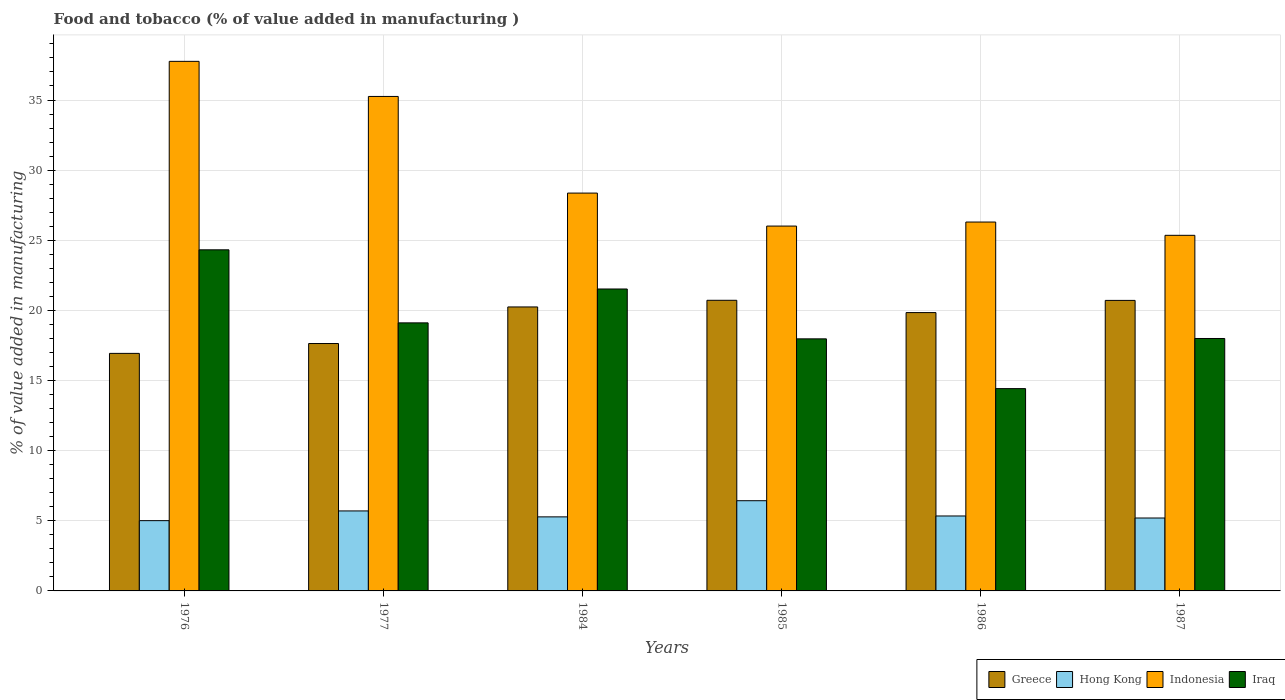Are the number of bars on each tick of the X-axis equal?
Offer a terse response. Yes. How many bars are there on the 3rd tick from the right?
Keep it short and to the point. 4. What is the label of the 1st group of bars from the left?
Keep it short and to the point. 1976. In how many cases, is the number of bars for a given year not equal to the number of legend labels?
Provide a short and direct response. 0. What is the value added in manufacturing food and tobacco in Iraq in 1985?
Make the answer very short. 17.97. Across all years, what is the maximum value added in manufacturing food and tobacco in Greece?
Ensure brevity in your answer.  20.72. Across all years, what is the minimum value added in manufacturing food and tobacco in Greece?
Ensure brevity in your answer.  16.93. In which year was the value added in manufacturing food and tobacco in Hong Kong minimum?
Your response must be concise. 1976. What is the total value added in manufacturing food and tobacco in Hong Kong in the graph?
Make the answer very short. 32.97. What is the difference between the value added in manufacturing food and tobacco in Hong Kong in 1984 and that in 1986?
Ensure brevity in your answer.  -0.06. What is the difference between the value added in manufacturing food and tobacco in Greece in 1977 and the value added in manufacturing food and tobacco in Iraq in 1976?
Keep it short and to the point. -6.68. What is the average value added in manufacturing food and tobacco in Indonesia per year?
Offer a terse response. 29.84. In the year 1987, what is the difference between the value added in manufacturing food and tobacco in Greece and value added in manufacturing food and tobacco in Hong Kong?
Your answer should be very brief. 15.51. In how many years, is the value added in manufacturing food and tobacco in Iraq greater than 22 %?
Give a very brief answer. 1. What is the ratio of the value added in manufacturing food and tobacco in Indonesia in 1976 to that in 1985?
Make the answer very short. 1.45. Is the value added in manufacturing food and tobacco in Hong Kong in 1977 less than that in 1986?
Keep it short and to the point. No. What is the difference between the highest and the second highest value added in manufacturing food and tobacco in Hong Kong?
Provide a short and direct response. 0.73. What is the difference between the highest and the lowest value added in manufacturing food and tobacco in Iraq?
Your answer should be compact. 9.9. Is it the case that in every year, the sum of the value added in manufacturing food and tobacco in Iraq and value added in manufacturing food and tobacco in Hong Kong is greater than the sum of value added in manufacturing food and tobacco in Greece and value added in manufacturing food and tobacco in Indonesia?
Your answer should be compact. Yes. What does the 2nd bar from the left in 1985 represents?
Ensure brevity in your answer.  Hong Kong. What does the 2nd bar from the right in 1977 represents?
Provide a short and direct response. Indonesia. Is it the case that in every year, the sum of the value added in manufacturing food and tobacco in Hong Kong and value added in manufacturing food and tobacco in Indonesia is greater than the value added in manufacturing food and tobacco in Iraq?
Your answer should be compact. Yes. How many bars are there?
Keep it short and to the point. 24. How many years are there in the graph?
Your answer should be very brief. 6. Are the values on the major ticks of Y-axis written in scientific E-notation?
Your answer should be compact. No. Does the graph contain grids?
Offer a very short reply. Yes. How are the legend labels stacked?
Your response must be concise. Horizontal. What is the title of the graph?
Make the answer very short. Food and tobacco (% of value added in manufacturing ). What is the label or title of the Y-axis?
Offer a very short reply. % of value added in manufacturing. What is the % of value added in manufacturing in Greece in 1976?
Provide a succinct answer. 16.93. What is the % of value added in manufacturing of Hong Kong in 1976?
Provide a short and direct response. 5.01. What is the % of value added in manufacturing in Indonesia in 1976?
Your answer should be very brief. 37.76. What is the % of value added in manufacturing in Iraq in 1976?
Provide a succinct answer. 24.32. What is the % of value added in manufacturing of Greece in 1977?
Your response must be concise. 17.64. What is the % of value added in manufacturing in Hong Kong in 1977?
Give a very brief answer. 5.7. What is the % of value added in manufacturing in Indonesia in 1977?
Offer a very short reply. 35.25. What is the % of value added in manufacturing of Iraq in 1977?
Your answer should be very brief. 19.11. What is the % of value added in manufacturing in Greece in 1984?
Your answer should be very brief. 20.25. What is the % of value added in manufacturing in Hong Kong in 1984?
Ensure brevity in your answer.  5.28. What is the % of value added in manufacturing in Indonesia in 1984?
Provide a short and direct response. 28.36. What is the % of value added in manufacturing of Iraq in 1984?
Provide a short and direct response. 21.53. What is the % of value added in manufacturing in Greece in 1985?
Provide a succinct answer. 20.72. What is the % of value added in manufacturing of Hong Kong in 1985?
Provide a short and direct response. 6.43. What is the % of value added in manufacturing in Indonesia in 1985?
Your answer should be very brief. 26.01. What is the % of value added in manufacturing of Iraq in 1985?
Keep it short and to the point. 17.97. What is the % of value added in manufacturing of Greece in 1986?
Make the answer very short. 19.84. What is the % of value added in manufacturing in Hong Kong in 1986?
Give a very brief answer. 5.34. What is the % of value added in manufacturing in Indonesia in 1986?
Offer a very short reply. 26.3. What is the % of value added in manufacturing in Iraq in 1986?
Make the answer very short. 14.42. What is the % of value added in manufacturing of Greece in 1987?
Ensure brevity in your answer.  20.71. What is the % of value added in manufacturing of Hong Kong in 1987?
Offer a very short reply. 5.2. What is the % of value added in manufacturing of Indonesia in 1987?
Make the answer very short. 25.35. What is the % of value added in manufacturing of Iraq in 1987?
Your answer should be very brief. 18. Across all years, what is the maximum % of value added in manufacturing of Greece?
Make the answer very short. 20.72. Across all years, what is the maximum % of value added in manufacturing in Hong Kong?
Give a very brief answer. 6.43. Across all years, what is the maximum % of value added in manufacturing in Indonesia?
Ensure brevity in your answer.  37.76. Across all years, what is the maximum % of value added in manufacturing in Iraq?
Keep it short and to the point. 24.32. Across all years, what is the minimum % of value added in manufacturing of Greece?
Offer a terse response. 16.93. Across all years, what is the minimum % of value added in manufacturing in Hong Kong?
Keep it short and to the point. 5.01. Across all years, what is the minimum % of value added in manufacturing of Indonesia?
Provide a succinct answer. 25.35. Across all years, what is the minimum % of value added in manufacturing in Iraq?
Offer a terse response. 14.42. What is the total % of value added in manufacturing in Greece in the graph?
Your response must be concise. 116.1. What is the total % of value added in manufacturing of Hong Kong in the graph?
Keep it short and to the point. 32.97. What is the total % of value added in manufacturing of Indonesia in the graph?
Your response must be concise. 179.04. What is the total % of value added in manufacturing in Iraq in the graph?
Your response must be concise. 115.35. What is the difference between the % of value added in manufacturing of Greece in 1976 and that in 1977?
Your answer should be compact. -0.7. What is the difference between the % of value added in manufacturing of Hong Kong in 1976 and that in 1977?
Provide a succinct answer. -0.69. What is the difference between the % of value added in manufacturing of Indonesia in 1976 and that in 1977?
Your answer should be very brief. 2.5. What is the difference between the % of value added in manufacturing of Iraq in 1976 and that in 1977?
Your answer should be compact. 5.21. What is the difference between the % of value added in manufacturing of Greece in 1976 and that in 1984?
Your answer should be compact. -3.31. What is the difference between the % of value added in manufacturing of Hong Kong in 1976 and that in 1984?
Give a very brief answer. -0.27. What is the difference between the % of value added in manufacturing of Indonesia in 1976 and that in 1984?
Give a very brief answer. 9.39. What is the difference between the % of value added in manufacturing in Iraq in 1976 and that in 1984?
Provide a short and direct response. 2.79. What is the difference between the % of value added in manufacturing in Greece in 1976 and that in 1985?
Offer a terse response. -3.79. What is the difference between the % of value added in manufacturing in Hong Kong in 1976 and that in 1985?
Provide a short and direct response. -1.42. What is the difference between the % of value added in manufacturing in Indonesia in 1976 and that in 1985?
Your answer should be very brief. 11.74. What is the difference between the % of value added in manufacturing in Iraq in 1976 and that in 1985?
Offer a very short reply. 6.35. What is the difference between the % of value added in manufacturing of Greece in 1976 and that in 1986?
Provide a succinct answer. -2.91. What is the difference between the % of value added in manufacturing of Hong Kong in 1976 and that in 1986?
Make the answer very short. -0.33. What is the difference between the % of value added in manufacturing in Indonesia in 1976 and that in 1986?
Provide a succinct answer. 11.46. What is the difference between the % of value added in manufacturing in Iraq in 1976 and that in 1986?
Give a very brief answer. 9.9. What is the difference between the % of value added in manufacturing in Greece in 1976 and that in 1987?
Provide a short and direct response. -3.78. What is the difference between the % of value added in manufacturing of Hong Kong in 1976 and that in 1987?
Offer a terse response. -0.19. What is the difference between the % of value added in manufacturing in Indonesia in 1976 and that in 1987?
Provide a succinct answer. 12.4. What is the difference between the % of value added in manufacturing of Iraq in 1976 and that in 1987?
Keep it short and to the point. 6.32. What is the difference between the % of value added in manufacturing in Greece in 1977 and that in 1984?
Your response must be concise. -2.61. What is the difference between the % of value added in manufacturing of Hong Kong in 1977 and that in 1984?
Ensure brevity in your answer.  0.42. What is the difference between the % of value added in manufacturing in Indonesia in 1977 and that in 1984?
Make the answer very short. 6.89. What is the difference between the % of value added in manufacturing of Iraq in 1977 and that in 1984?
Offer a terse response. -2.42. What is the difference between the % of value added in manufacturing in Greece in 1977 and that in 1985?
Make the answer very short. -3.08. What is the difference between the % of value added in manufacturing in Hong Kong in 1977 and that in 1985?
Give a very brief answer. -0.73. What is the difference between the % of value added in manufacturing of Indonesia in 1977 and that in 1985?
Provide a succinct answer. 9.24. What is the difference between the % of value added in manufacturing of Iraq in 1977 and that in 1985?
Give a very brief answer. 1.14. What is the difference between the % of value added in manufacturing in Greece in 1977 and that in 1986?
Offer a very short reply. -2.21. What is the difference between the % of value added in manufacturing in Hong Kong in 1977 and that in 1986?
Keep it short and to the point. 0.36. What is the difference between the % of value added in manufacturing of Indonesia in 1977 and that in 1986?
Your answer should be compact. 8.95. What is the difference between the % of value added in manufacturing of Iraq in 1977 and that in 1986?
Your answer should be very brief. 4.69. What is the difference between the % of value added in manufacturing of Greece in 1977 and that in 1987?
Your answer should be very brief. -3.07. What is the difference between the % of value added in manufacturing of Hong Kong in 1977 and that in 1987?
Your response must be concise. 0.5. What is the difference between the % of value added in manufacturing in Indonesia in 1977 and that in 1987?
Ensure brevity in your answer.  9.9. What is the difference between the % of value added in manufacturing of Iraq in 1977 and that in 1987?
Your response must be concise. 1.11. What is the difference between the % of value added in manufacturing of Greece in 1984 and that in 1985?
Ensure brevity in your answer.  -0.48. What is the difference between the % of value added in manufacturing in Hong Kong in 1984 and that in 1985?
Your response must be concise. -1.15. What is the difference between the % of value added in manufacturing of Indonesia in 1984 and that in 1985?
Offer a very short reply. 2.35. What is the difference between the % of value added in manufacturing in Iraq in 1984 and that in 1985?
Ensure brevity in your answer.  3.56. What is the difference between the % of value added in manufacturing in Greece in 1984 and that in 1986?
Offer a very short reply. 0.4. What is the difference between the % of value added in manufacturing of Hong Kong in 1984 and that in 1986?
Your answer should be very brief. -0.06. What is the difference between the % of value added in manufacturing of Indonesia in 1984 and that in 1986?
Make the answer very short. 2.06. What is the difference between the % of value added in manufacturing in Iraq in 1984 and that in 1986?
Offer a very short reply. 7.1. What is the difference between the % of value added in manufacturing in Greece in 1984 and that in 1987?
Give a very brief answer. -0.47. What is the difference between the % of value added in manufacturing in Hong Kong in 1984 and that in 1987?
Offer a terse response. 0.08. What is the difference between the % of value added in manufacturing of Indonesia in 1984 and that in 1987?
Provide a short and direct response. 3.01. What is the difference between the % of value added in manufacturing in Iraq in 1984 and that in 1987?
Keep it short and to the point. 3.53. What is the difference between the % of value added in manufacturing in Greece in 1985 and that in 1986?
Provide a short and direct response. 0.88. What is the difference between the % of value added in manufacturing in Hong Kong in 1985 and that in 1986?
Your response must be concise. 1.09. What is the difference between the % of value added in manufacturing in Indonesia in 1985 and that in 1986?
Offer a terse response. -0.29. What is the difference between the % of value added in manufacturing of Iraq in 1985 and that in 1986?
Make the answer very short. 3.55. What is the difference between the % of value added in manufacturing of Greece in 1985 and that in 1987?
Ensure brevity in your answer.  0.01. What is the difference between the % of value added in manufacturing in Hong Kong in 1985 and that in 1987?
Keep it short and to the point. 1.23. What is the difference between the % of value added in manufacturing of Indonesia in 1985 and that in 1987?
Keep it short and to the point. 0.66. What is the difference between the % of value added in manufacturing in Iraq in 1985 and that in 1987?
Your response must be concise. -0.03. What is the difference between the % of value added in manufacturing in Greece in 1986 and that in 1987?
Your answer should be compact. -0.87. What is the difference between the % of value added in manufacturing in Hong Kong in 1986 and that in 1987?
Provide a succinct answer. 0.15. What is the difference between the % of value added in manufacturing of Indonesia in 1986 and that in 1987?
Offer a very short reply. 0.95. What is the difference between the % of value added in manufacturing in Iraq in 1986 and that in 1987?
Keep it short and to the point. -3.57. What is the difference between the % of value added in manufacturing in Greece in 1976 and the % of value added in manufacturing in Hong Kong in 1977?
Make the answer very short. 11.23. What is the difference between the % of value added in manufacturing in Greece in 1976 and the % of value added in manufacturing in Indonesia in 1977?
Give a very brief answer. -18.32. What is the difference between the % of value added in manufacturing of Greece in 1976 and the % of value added in manufacturing of Iraq in 1977?
Give a very brief answer. -2.18. What is the difference between the % of value added in manufacturing in Hong Kong in 1976 and the % of value added in manufacturing in Indonesia in 1977?
Offer a very short reply. -30.24. What is the difference between the % of value added in manufacturing in Hong Kong in 1976 and the % of value added in manufacturing in Iraq in 1977?
Give a very brief answer. -14.1. What is the difference between the % of value added in manufacturing of Indonesia in 1976 and the % of value added in manufacturing of Iraq in 1977?
Provide a short and direct response. 18.64. What is the difference between the % of value added in manufacturing of Greece in 1976 and the % of value added in manufacturing of Hong Kong in 1984?
Provide a short and direct response. 11.66. What is the difference between the % of value added in manufacturing of Greece in 1976 and the % of value added in manufacturing of Indonesia in 1984?
Make the answer very short. -11.43. What is the difference between the % of value added in manufacturing in Greece in 1976 and the % of value added in manufacturing in Iraq in 1984?
Offer a very short reply. -4.59. What is the difference between the % of value added in manufacturing in Hong Kong in 1976 and the % of value added in manufacturing in Indonesia in 1984?
Your response must be concise. -23.35. What is the difference between the % of value added in manufacturing of Hong Kong in 1976 and the % of value added in manufacturing of Iraq in 1984?
Offer a terse response. -16.52. What is the difference between the % of value added in manufacturing in Indonesia in 1976 and the % of value added in manufacturing in Iraq in 1984?
Your response must be concise. 16.23. What is the difference between the % of value added in manufacturing of Greece in 1976 and the % of value added in manufacturing of Hong Kong in 1985?
Make the answer very short. 10.5. What is the difference between the % of value added in manufacturing in Greece in 1976 and the % of value added in manufacturing in Indonesia in 1985?
Keep it short and to the point. -9.08. What is the difference between the % of value added in manufacturing of Greece in 1976 and the % of value added in manufacturing of Iraq in 1985?
Give a very brief answer. -1.04. What is the difference between the % of value added in manufacturing of Hong Kong in 1976 and the % of value added in manufacturing of Indonesia in 1985?
Your response must be concise. -21. What is the difference between the % of value added in manufacturing in Hong Kong in 1976 and the % of value added in manufacturing in Iraq in 1985?
Offer a very short reply. -12.96. What is the difference between the % of value added in manufacturing of Indonesia in 1976 and the % of value added in manufacturing of Iraq in 1985?
Give a very brief answer. 19.78. What is the difference between the % of value added in manufacturing of Greece in 1976 and the % of value added in manufacturing of Hong Kong in 1986?
Your answer should be very brief. 11.59. What is the difference between the % of value added in manufacturing in Greece in 1976 and the % of value added in manufacturing in Indonesia in 1986?
Make the answer very short. -9.36. What is the difference between the % of value added in manufacturing of Greece in 1976 and the % of value added in manufacturing of Iraq in 1986?
Keep it short and to the point. 2.51. What is the difference between the % of value added in manufacturing of Hong Kong in 1976 and the % of value added in manufacturing of Indonesia in 1986?
Make the answer very short. -21.29. What is the difference between the % of value added in manufacturing of Hong Kong in 1976 and the % of value added in manufacturing of Iraq in 1986?
Provide a short and direct response. -9.41. What is the difference between the % of value added in manufacturing of Indonesia in 1976 and the % of value added in manufacturing of Iraq in 1986?
Give a very brief answer. 23.33. What is the difference between the % of value added in manufacturing in Greece in 1976 and the % of value added in manufacturing in Hong Kong in 1987?
Offer a terse response. 11.74. What is the difference between the % of value added in manufacturing of Greece in 1976 and the % of value added in manufacturing of Indonesia in 1987?
Your answer should be very brief. -8.42. What is the difference between the % of value added in manufacturing of Greece in 1976 and the % of value added in manufacturing of Iraq in 1987?
Give a very brief answer. -1.06. What is the difference between the % of value added in manufacturing in Hong Kong in 1976 and the % of value added in manufacturing in Indonesia in 1987?
Offer a very short reply. -20.34. What is the difference between the % of value added in manufacturing in Hong Kong in 1976 and the % of value added in manufacturing in Iraq in 1987?
Offer a terse response. -12.99. What is the difference between the % of value added in manufacturing of Indonesia in 1976 and the % of value added in manufacturing of Iraq in 1987?
Your answer should be compact. 19.76. What is the difference between the % of value added in manufacturing of Greece in 1977 and the % of value added in manufacturing of Hong Kong in 1984?
Make the answer very short. 12.36. What is the difference between the % of value added in manufacturing of Greece in 1977 and the % of value added in manufacturing of Indonesia in 1984?
Offer a terse response. -10.73. What is the difference between the % of value added in manufacturing of Greece in 1977 and the % of value added in manufacturing of Iraq in 1984?
Provide a short and direct response. -3.89. What is the difference between the % of value added in manufacturing in Hong Kong in 1977 and the % of value added in manufacturing in Indonesia in 1984?
Provide a short and direct response. -22.66. What is the difference between the % of value added in manufacturing of Hong Kong in 1977 and the % of value added in manufacturing of Iraq in 1984?
Ensure brevity in your answer.  -15.82. What is the difference between the % of value added in manufacturing in Indonesia in 1977 and the % of value added in manufacturing in Iraq in 1984?
Provide a short and direct response. 13.73. What is the difference between the % of value added in manufacturing of Greece in 1977 and the % of value added in manufacturing of Hong Kong in 1985?
Your response must be concise. 11.21. What is the difference between the % of value added in manufacturing in Greece in 1977 and the % of value added in manufacturing in Indonesia in 1985?
Your response must be concise. -8.37. What is the difference between the % of value added in manufacturing of Greece in 1977 and the % of value added in manufacturing of Iraq in 1985?
Keep it short and to the point. -0.33. What is the difference between the % of value added in manufacturing in Hong Kong in 1977 and the % of value added in manufacturing in Indonesia in 1985?
Ensure brevity in your answer.  -20.31. What is the difference between the % of value added in manufacturing of Hong Kong in 1977 and the % of value added in manufacturing of Iraq in 1985?
Your answer should be compact. -12.27. What is the difference between the % of value added in manufacturing of Indonesia in 1977 and the % of value added in manufacturing of Iraq in 1985?
Provide a succinct answer. 17.28. What is the difference between the % of value added in manufacturing in Greece in 1977 and the % of value added in manufacturing in Hong Kong in 1986?
Provide a succinct answer. 12.29. What is the difference between the % of value added in manufacturing of Greece in 1977 and the % of value added in manufacturing of Indonesia in 1986?
Your answer should be compact. -8.66. What is the difference between the % of value added in manufacturing of Greece in 1977 and the % of value added in manufacturing of Iraq in 1986?
Provide a short and direct response. 3.21. What is the difference between the % of value added in manufacturing in Hong Kong in 1977 and the % of value added in manufacturing in Indonesia in 1986?
Make the answer very short. -20.6. What is the difference between the % of value added in manufacturing of Hong Kong in 1977 and the % of value added in manufacturing of Iraq in 1986?
Offer a very short reply. -8.72. What is the difference between the % of value added in manufacturing of Indonesia in 1977 and the % of value added in manufacturing of Iraq in 1986?
Offer a terse response. 20.83. What is the difference between the % of value added in manufacturing in Greece in 1977 and the % of value added in manufacturing in Hong Kong in 1987?
Keep it short and to the point. 12.44. What is the difference between the % of value added in manufacturing of Greece in 1977 and the % of value added in manufacturing of Indonesia in 1987?
Make the answer very short. -7.71. What is the difference between the % of value added in manufacturing of Greece in 1977 and the % of value added in manufacturing of Iraq in 1987?
Your answer should be compact. -0.36. What is the difference between the % of value added in manufacturing of Hong Kong in 1977 and the % of value added in manufacturing of Indonesia in 1987?
Provide a succinct answer. -19.65. What is the difference between the % of value added in manufacturing in Hong Kong in 1977 and the % of value added in manufacturing in Iraq in 1987?
Your answer should be very brief. -12.29. What is the difference between the % of value added in manufacturing in Indonesia in 1977 and the % of value added in manufacturing in Iraq in 1987?
Give a very brief answer. 17.26. What is the difference between the % of value added in manufacturing in Greece in 1984 and the % of value added in manufacturing in Hong Kong in 1985?
Provide a short and direct response. 13.81. What is the difference between the % of value added in manufacturing of Greece in 1984 and the % of value added in manufacturing of Indonesia in 1985?
Your answer should be compact. -5.77. What is the difference between the % of value added in manufacturing of Greece in 1984 and the % of value added in manufacturing of Iraq in 1985?
Offer a terse response. 2.27. What is the difference between the % of value added in manufacturing of Hong Kong in 1984 and the % of value added in manufacturing of Indonesia in 1985?
Make the answer very short. -20.73. What is the difference between the % of value added in manufacturing in Hong Kong in 1984 and the % of value added in manufacturing in Iraq in 1985?
Your answer should be very brief. -12.69. What is the difference between the % of value added in manufacturing in Indonesia in 1984 and the % of value added in manufacturing in Iraq in 1985?
Your answer should be compact. 10.39. What is the difference between the % of value added in manufacturing of Greece in 1984 and the % of value added in manufacturing of Hong Kong in 1986?
Keep it short and to the point. 14.9. What is the difference between the % of value added in manufacturing of Greece in 1984 and the % of value added in manufacturing of Indonesia in 1986?
Keep it short and to the point. -6.05. What is the difference between the % of value added in manufacturing in Greece in 1984 and the % of value added in manufacturing in Iraq in 1986?
Keep it short and to the point. 5.82. What is the difference between the % of value added in manufacturing of Hong Kong in 1984 and the % of value added in manufacturing of Indonesia in 1986?
Provide a succinct answer. -21.02. What is the difference between the % of value added in manufacturing in Hong Kong in 1984 and the % of value added in manufacturing in Iraq in 1986?
Your response must be concise. -9.14. What is the difference between the % of value added in manufacturing of Indonesia in 1984 and the % of value added in manufacturing of Iraq in 1986?
Your response must be concise. 13.94. What is the difference between the % of value added in manufacturing of Greece in 1984 and the % of value added in manufacturing of Hong Kong in 1987?
Keep it short and to the point. 15.05. What is the difference between the % of value added in manufacturing in Greece in 1984 and the % of value added in manufacturing in Indonesia in 1987?
Your response must be concise. -5.11. What is the difference between the % of value added in manufacturing in Greece in 1984 and the % of value added in manufacturing in Iraq in 1987?
Your answer should be very brief. 2.25. What is the difference between the % of value added in manufacturing in Hong Kong in 1984 and the % of value added in manufacturing in Indonesia in 1987?
Keep it short and to the point. -20.07. What is the difference between the % of value added in manufacturing in Hong Kong in 1984 and the % of value added in manufacturing in Iraq in 1987?
Offer a terse response. -12.72. What is the difference between the % of value added in manufacturing of Indonesia in 1984 and the % of value added in manufacturing of Iraq in 1987?
Make the answer very short. 10.37. What is the difference between the % of value added in manufacturing of Greece in 1985 and the % of value added in manufacturing of Hong Kong in 1986?
Provide a short and direct response. 15.38. What is the difference between the % of value added in manufacturing of Greece in 1985 and the % of value added in manufacturing of Indonesia in 1986?
Offer a terse response. -5.58. What is the difference between the % of value added in manufacturing of Greece in 1985 and the % of value added in manufacturing of Iraq in 1986?
Your answer should be compact. 6.3. What is the difference between the % of value added in manufacturing in Hong Kong in 1985 and the % of value added in manufacturing in Indonesia in 1986?
Offer a very short reply. -19.87. What is the difference between the % of value added in manufacturing in Hong Kong in 1985 and the % of value added in manufacturing in Iraq in 1986?
Make the answer very short. -7.99. What is the difference between the % of value added in manufacturing in Indonesia in 1985 and the % of value added in manufacturing in Iraq in 1986?
Your response must be concise. 11.59. What is the difference between the % of value added in manufacturing of Greece in 1985 and the % of value added in manufacturing of Hong Kong in 1987?
Give a very brief answer. 15.52. What is the difference between the % of value added in manufacturing of Greece in 1985 and the % of value added in manufacturing of Indonesia in 1987?
Offer a terse response. -4.63. What is the difference between the % of value added in manufacturing in Greece in 1985 and the % of value added in manufacturing in Iraq in 1987?
Your answer should be compact. 2.72. What is the difference between the % of value added in manufacturing of Hong Kong in 1985 and the % of value added in manufacturing of Indonesia in 1987?
Offer a very short reply. -18.92. What is the difference between the % of value added in manufacturing of Hong Kong in 1985 and the % of value added in manufacturing of Iraq in 1987?
Provide a succinct answer. -11.57. What is the difference between the % of value added in manufacturing in Indonesia in 1985 and the % of value added in manufacturing in Iraq in 1987?
Offer a terse response. 8.02. What is the difference between the % of value added in manufacturing of Greece in 1986 and the % of value added in manufacturing of Hong Kong in 1987?
Ensure brevity in your answer.  14.65. What is the difference between the % of value added in manufacturing in Greece in 1986 and the % of value added in manufacturing in Indonesia in 1987?
Offer a terse response. -5.51. What is the difference between the % of value added in manufacturing in Greece in 1986 and the % of value added in manufacturing in Iraq in 1987?
Keep it short and to the point. 1.85. What is the difference between the % of value added in manufacturing in Hong Kong in 1986 and the % of value added in manufacturing in Indonesia in 1987?
Keep it short and to the point. -20.01. What is the difference between the % of value added in manufacturing in Hong Kong in 1986 and the % of value added in manufacturing in Iraq in 1987?
Ensure brevity in your answer.  -12.65. What is the difference between the % of value added in manufacturing of Indonesia in 1986 and the % of value added in manufacturing of Iraq in 1987?
Offer a very short reply. 8.3. What is the average % of value added in manufacturing of Greece per year?
Give a very brief answer. 19.35. What is the average % of value added in manufacturing of Hong Kong per year?
Offer a terse response. 5.49. What is the average % of value added in manufacturing in Indonesia per year?
Your response must be concise. 29.84. What is the average % of value added in manufacturing in Iraq per year?
Your answer should be very brief. 19.22. In the year 1976, what is the difference between the % of value added in manufacturing of Greece and % of value added in manufacturing of Hong Kong?
Offer a terse response. 11.92. In the year 1976, what is the difference between the % of value added in manufacturing in Greece and % of value added in manufacturing in Indonesia?
Your response must be concise. -20.82. In the year 1976, what is the difference between the % of value added in manufacturing of Greece and % of value added in manufacturing of Iraq?
Keep it short and to the point. -7.38. In the year 1976, what is the difference between the % of value added in manufacturing in Hong Kong and % of value added in manufacturing in Indonesia?
Keep it short and to the point. -32.75. In the year 1976, what is the difference between the % of value added in manufacturing of Hong Kong and % of value added in manufacturing of Iraq?
Make the answer very short. -19.31. In the year 1976, what is the difference between the % of value added in manufacturing of Indonesia and % of value added in manufacturing of Iraq?
Give a very brief answer. 13.44. In the year 1977, what is the difference between the % of value added in manufacturing of Greece and % of value added in manufacturing of Hong Kong?
Offer a very short reply. 11.94. In the year 1977, what is the difference between the % of value added in manufacturing of Greece and % of value added in manufacturing of Indonesia?
Your answer should be compact. -17.62. In the year 1977, what is the difference between the % of value added in manufacturing in Greece and % of value added in manufacturing in Iraq?
Offer a very short reply. -1.47. In the year 1977, what is the difference between the % of value added in manufacturing in Hong Kong and % of value added in manufacturing in Indonesia?
Offer a very short reply. -29.55. In the year 1977, what is the difference between the % of value added in manufacturing in Hong Kong and % of value added in manufacturing in Iraq?
Keep it short and to the point. -13.41. In the year 1977, what is the difference between the % of value added in manufacturing of Indonesia and % of value added in manufacturing of Iraq?
Offer a very short reply. 16.14. In the year 1984, what is the difference between the % of value added in manufacturing in Greece and % of value added in manufacturing in Hong Kong?
Your answer should be very brief. 14.97. In the year 1984, what is the difference between the % of value added in manufacturing in Greece and % of value added in manufacturing in Indonesia?
Provide a succinct answer. -8.12. In the year 1984, what is the difference between the % of value added in manufacturing in Greece and % of value added in manufacturing in Iraq?
Your answer should be compact. -1.28. In the year 1984, what is the difference between the % of value added in manufacturing in Hong Kong and % of value added in manufacturing in Indonesia?
Make the answer very short. -23.08. In the year 1984, what is the difference between the % of value added in manufacturing in Hong Kong and % of value added in manufacturing in Iraq?
Your answer should be very brief. -16.25. In the year 1984, what is the difference between the % of value added in manufacturing of Indonesia and % of value added in manufacturing of Iraq?
Provide a succinct answer. 6.84. In the year 1985, what is the difference between the % of value added in manufacturing in Greece and % of value added in manufacturing in Hong Kong?
Make the answer very short. 14.29. In the year 1985, what is the difference between the % of value added in manufacturing in Greece and % of value added in manufacturing in Indonesia?
Your response must be concise. -5.29. In the year 1985, what is the difference between the % of value added in manufacturing in Greece and % of value added in manufacturing in Iraq?
Offer a terse response. 2.75. In the year 1985, what is the difference between the % of value added in manufacturing in Hong Kong and % of value added in manufacturing in Indonesia?
Offer a very short reply. -19.58. In the year 1985, what is the difference between the % of value added in manufacturing in Hong Kong and % of value added in manufacturing in Iraq?
Provide a short and direct response. -11.54. In the year 1985, what is the difference between the % of value added in manufacturing of Indonesia and % of value added in manufacturing of Iraq?
Your answer should be compact. 8.04. In the year 1986, what is the difference between the % of value added in manufacturing in Greece and % of value added in manufacturing in Hong Kong?
Make the answer very short. 14.5. In the year 1986, what is the difference between the % of value added in manufacturing in Greece and % of value added in manufacturing in Indonesia?
Offer a very short reply. -6.46. In the year 1986, what is the difference between the % of value added in manufacturing in Greece and % of value added in manufacturing in Iraq?
Keep it short and to the point. 5.42. In the year 1986, what is the difference between the % of value added in manufacturing in Hong Kong and % of value added in manufacturing in Indonesia?
Keep it short and to the point. -20.96. In the year 1986, what is the difference between the % of value added in manufacturing of Hong Kong and % of value added in manufacturing of Iraq?
Offer a very short reply. -9.08. In the year 1986, what is the difference between the % of value added in manufacturing of Indonesia and % of value added in manufacturing of Iraq?
Your answer should be very brief. 11.88. In the year 1987, what is the difference between the % of value added in manufacturing of Greece and % of value added in manufacturing of Hong Kong?
Make the answer very short. 15.51. In the year 1987, what is the difference between the % of value added in manufacturing in Greece and % of value added in manufacturing in Indonesia?
Provide a succinct answer. -4.64. In the year 1987, what is the difference between the % of value added in manufacturing of Greece and % of value added in manufacturing of Iraq?
Your answer should be very brief. 2.72. In the year 1987, what is the difference between the % of value added in manufacturing in Hong Kong and % of value added in manufacturing in Indonesia?
Give a very brief answer. -20.15. In the year 1987, what is the difference between the % of value added in manufacturing of Hong Kong and % of value added in manufacturing of Iraq?
Your answer should be very brief. -12.8. In the year 1987, what is the difference between the % of value added in manufacturing of Indonesia and % of value added in manufacturing of Iraq?
Give a very brief answer. 7.36. What is the ratio of the % of value added in manufacturing of Greece in 1976 to that in 1977?
Your response must be concise. 0.96. What is the ratio of the % of value added in manufacturing of Hong Kong in 1976 to that in 1977?
Give a very brief answer. 0.88. What is the ratio of the % of value added in manufacturing in Indonesia in 1976 to that in 1977?
Offer a very short reply. 1.07. What is the ratio of the % of value added in manufacturing of Iraq in 1976 to that in 1977?
Ensure brevity in your answer.  1.27. What is the ratio of the % of value added in manufacturing in Greece in 1976 to that in 1984?
Your answer should be compact. 0.84. What is the ratio of the % of value added in manufacturing of Hong Kong in 1976 to that in 1984?
Provide a short and direct response. 0.95. What is the ratio of the % of value added in manufacturing of Indonesia in 1976 to that in 1984?
Ensure brevity in your answer.  1.33. What is the ratio of the % of value added in manufacturing of Iraq in 1976 to that in 1984?
Ensure brevity in your answer.  1.13. What is the ratio of the % of value added in manufacturing in Greece in 1976 to that in 1985?
Offer a terse response. 0.82. What is the ratio of the % of value added in manufacturing in Hong Kong in 1976 to that in 1985?
Your response must be concise. 0.78. What is the ratio of the % of value added in manufacturing in Indonesia in 1976 to that in 1985?
Offer a terse response. 1.45. What is the ratio of the % of value added in manufacturing in Iraq in 1976 to that in 1985?
Offer a very short reply. 1.35. What is the ratio of the % of value added in manufacturing of Greece in 1976 to that in 1986?
Ensure brevity in your answer.  0.85. What is the ratio of the % of value added in manufacturing in Hong Kong in 1976 to that in 1986?
Offer a very short reply. 0.94. What is the ratio of the % of value added in manufacturing in Indonesia in 1976 to that in 1986?
Your response must be concise. 1.44. What is the ratio of the % of value added in manufacturing in Iraq in 1976 to that in 1986?
Provide a succinct answer. 1.69. What is the ratio of the % of value added in manufacturing of Greece in 1976 to that in 1987?
Your response must be concise. 0.82. What is the ratio of the % of value added in manufacturing in Hong Kong in 1976 to that in 1987?
Ensure brevity in your answer.  0.96. What is the ratio of the % of value added in manufacturing of Indonesia in 1976 to that in 1987?
Make the answer very short. 1.49. What is the ratio of the % of value added in manufacturing in Iraq in 1976 to that in 1987?
Ensure brevity in your answer.  1.35. What is the ratio of the % of value added in manufacturing in Greece in 1977 to that in 1984?
Your response must be concise. 0.87. What is the ratio of the % of value added in manufacturing of Hong Kong in 1977 to that in 1984?
Your response must be concise. 1.08. What is the ratio of the % of value added in manufacturing in Indonesia in 1977 to that in 1984?
Offer a very short reply. 1.24. What is the ratio of the % of value added in manufacturing of Iraq in 1977 to that in 1984?
Keep it short and to the point. 0.89. What is the ratio of the % of value added in manufacturing in Greece in 1977 to that in 1985?
Your answer should be very brief. 0.85. What is the ratio of the % of value added in manufacturing of Hong Kong in 1977 to that in 1985?
Your answer should be very brief. 0.89. What is the ratio of the % of value added in manufacturing of Indonesia in 1977 to that in 1985?
Your response must be concise. 1.36. What is the ratio of the % of value added in manufacturing of Iraq in 1977 to that in 1985?
Your answer should be very brief. 1.06. What is the ratio of the % of value added in manufacturing of Greece in 1977 to that in 1986?
Provide a succinct answer. 0.89. What is the ratio of the % of value added in manufacturing in Hong Kong in 1977 to that in 1986?
Provide a succinct answer. 1.07. What is the ratio of the % of value added in manufacturing in Indonesia in 1977 to that in 1986?
Ensure brevity in your answer.  1.34. What is the ratio of the % of value added in manufacturing of Iraq in 1977 to that in 1986?
Offer a very short reply. 1.32. What is the ratio of the % of value added in manufacturing in Greece in 1977 to that in 1987?
Your answer should be very brief. 0.85. What is the ratio of the % of value added in manufacturing of Hong Kong in 1977 to that in 1987?
Offer a very short reply. 1.1. What is the ratio of the % of value added in manufacturing of Indonesia in 1977 to that in 1987?
Ensure brevity in your answer.  1.39. What is the ratio of the % of value added in manufacturing in Iraq in 1977 to that in 1987?
Provide a succinct answer. 1.06. What is the ratio of the % of value added in manufacturing in Greece in 1984 to that in 1985?
Your answer should be very brief. 0.98. What is the ratio of the % of value added in manufacturing in Hong Kong in 1984 to that in 1985?
Keep it short and to the point. 0.82. What is the ratio of the % of value added in manufacturing in Indonesia in 1984 to that in 1985?
Offer a terse response. 1.09. What is the ratio of the % of value added in manufacturing in Iraq in 1984 to that in 1985?
Your answer should be compact. 1.2. What is the ratio of the % of value added in manufacturing of Greece in 1984 to that in 1986?
Ensure brevity in your answer.  1.02. What is the ratio of the % of value added in manufacturing in Indonesia in 1984 to that in 1986?
Ensure brevity in your answer.  1.08. What is the ratio of the % of value added in manufacturing of Iraq in 1984 to that in 1986?
Your answer should be compact. 1.49. What is the ratio of the % of value added in manufacturing in Greece in 1984 to that in 1987?
Ensure brevity in your answer.  0.98. What is the ratio of the % of value added in manufacturing in Hong Kong in 1984 to that in 1987?
Ensure brevity in your answer.  1.02. What is the ratio of the % of value added in manufacturing in Indonesia in 1984 to that in 1987?
Ensure brevity in your answer.  1.12. What is the ratio of the % of value added in manufacturing of Iraq in 1984 to that in 1987?
Ensure brevity in your answer.  1.2. What is the ratio of the % of value added in manufacturing in Greece in 1985 to that in 1986?
Provide a short and direct response. 1.04. What is the ratio of the % of value added in manufacturing of Hong Kong in 1985 to that in 1986?
Provide a short and direct response. 1.2. What is the ratio of the % of value added in manufacturing of Indonesia in 1985 to that in 1986?
Give a very brief answer. 0.99. What is the ratio of the % of value added in manufacturing of Iraq in 1985 to that in 1986?
Ensure brevity in your answer.  1.25. What is the ratio of the % of value added in manufacturing in Hong Kong in 1985 to that in 1987?
Ensure brevity in your answer.  1.24. What is the ratio of the % of value added in manufacturing of Greece in 1986 to that in 1987?
Your answer should be compact. 0.96. What is the ratio of the % of value added in manufacturing in Hong Kong in 1986 to that in 1987?
Ensure brevity in your answer.  1.03. What is the ratio of the % of value added in manufacturing of Indonesia in 1986 to that in 1987?
Provide a succinct answer. 1.04. What is the ratio of the % of value added in manufacturing in Iraq in 1986 to that in 1987?
Make the answer very short. 0.8. What is the difference between the highest and the second highest % of value added in manufacturing in Greece?
Offer a very short reply. 0.01. What is the difference between the highest and the second highest % of value added in manufacturing of Hong Kong?
Your answer should be compact. 0.73. What is the difference between the highest and the second highest % of value added in manufacturing of Indonesia?
Ensure brevity in your answer.  2.5. What is the difference between the highest and the second highest % of value added in manufacturing of Iraq?
Ensure brevity in your answer.  2.79. What is the difference between the highest and the lowest % of value added in manufacturing in Greece?
Offer a very short reply. 3.79. What is the difference between the highest and the lowest % of value added in manufacturing of Hong Kong?
Make the answer very short. 1.42. What is the difference between the highest and the lowest % of value added in manufacturing in Indonesia?
Your answer should be very brief. 12.4. What is the difference between the highest and the lowest % of value added in manufacturing in Iraq?
Keep it short and to the point. 9.9. 